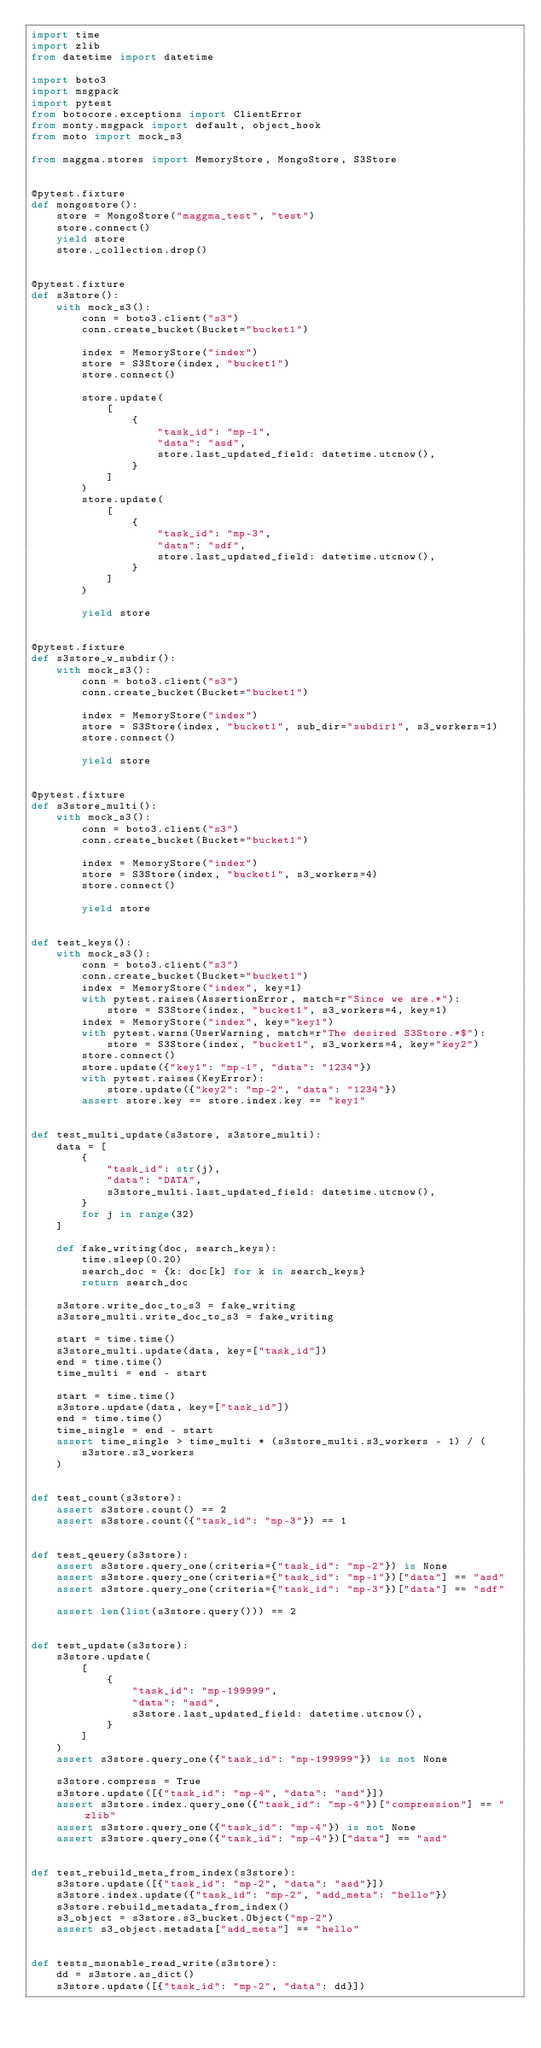<code> <loc_0><loc_0><loc_500><loc_500><_Python_>import time
import zlib
from datetime import datetime

import boto3
import msgpack
import pytest
from botocore.exceptions import ClientError
from monty.msgpack import default, object_hook
from moto import mock_s3

from maggma.stores import MemoryStore, MongoStore, S3Store


@pytest.fixture
def mongostore():
    store = MongoStore("maggma_test", "test")
    store.connect()
    yield store
    store._collection.drop()


@pytest.fixture
def s3store():
    with mock_s3():
        conn = boto3.client("s3")
        conn.create_bucket(Bucket="bucket1")

        index = MemoryStore("index")
        store = S3Store(index, "bucket1")
        store.connect()

        store.update(
            [
                {
                    "task_id": "mp-1",
                    "data": "asd",
                    store.last_updated_field: datetime.utcnow(),
                }
            ]
        )
        store.update(
            [
                {
                    "task_id": "mp-3",
                    "data": "sdf",
                    store.last_updated_field: datetime.utcnow(),
                }
            ]
        )

        yield store


@pytest.fixture
def s3store_w_subdir():
    with mock_s3():
        conn = boto3.client("s3")
        conn.create_bucket(Bucket="bucket1")

        index = MemoryStore("index")
        store = S3Store(index, "bucket1", sub_dir="subdir1", s3_workers=1)
        store.connect()

        yield store


@pytest.fixture
def s3store_multi():
    with mock_s3():
        conn = boto3.client("s3")
        conn.create_bucket(Bucket="bucket1")

        index = MemoryStore("index")
        store = S3Store(index, "bucket1", s3_workers=4)
        store.connect()

        yield store


def test_keys():
    with mock_s3():
        conn = boto3.client("s3")
        conn.create_bucket(Bucket="bucket1")
        index = MemoryStore("index", key=1)
        with pytest.raises(AssertionError, match=r"Since we are.*"):
            store = S3Store(index, "bucket1", s3_workers=4, key=1)
        index = MemoryStore("index", key="key1")
        with pytest.warns(UserWarning, match=r"The desired S3Store.*$"):
            store = S3Store(index, "bucket1", s3_workers=4, key="key2")
        store.connect()
        store.update({"key1": "mp-1", "data": "1234"})
        with pytest.raises(KeyError):
            store.update({"key2": "mp-2", "data": "1234"})
        assert store.key == store.index.key == "key1"


def test_multi_update(s3store, s3store_multi):
    data = [
        {
            "task_id": str(j),
            "data": "DATA",
            s3store_multi.last_updated_field: datetime.utcnow(),
        }
        for j in range(32)
    ]

    def fake_writing(doc, search_keys):
        time.sleep(0.20)
        search_doc = {k: doc[k] for k in search_keys}
        return search_doc

    s3store.write_doc_to_s3 = fake_writing
    s3store_multi.write_doc_to_s3 = fake_writing

    start = time.time()
    s3store_multi.update(data, key=["task_id"])
    end = time.time()
    time_multi = end - start

    start = time.time()
    s3store.update(data, key=["task_id"])
    end = time.time()
    time_single = end - start
    assert time_single > time_multi * (s3store_multi.s3_workers - 1) / (
        s3store.s3_workers
    )


def test_count(s3store):
    assert s3store.count() == 2
    assert s3store.count({"task_id": "mp-3"}) == 1


def test_qeuery(s3store):
    assert s3store.query_one(criteria={"task_id": "mp-2"}) is None
    assert s3store.query_one(criteria={"task_id": "mp-1"})["data"] == "asd"
    assert s3store.query_one(criteria={"task_id": "mp-3"})["data"] == "sdf"

    assert len(list(s3store.query())) == 2


def test_update(s3store):
    s3store.update(
        [
            {
                "task_id": "mp-199999",
                "data": "asd",
                s3store.last_updated_field: datetime.utcnow(),
            }
        ]
    )
    assert s3store.query_one({"task_id": "mp-199999"}) is not None

    s3store.compress = True
    s3store.update([{"task_id": "mp-4", "data": "asd"}])
    assert s3store.index.query_one({"task_id": "mp-4"})["compression"] == "zlib"
    assert s3store.query_one({"task_id": "mp-4"}) is not None
    assert s3store.query_one({"task_id": "mp-4"})["data"] == "asd"


def test_rebuild_meta_from_index(s3store):
    s3store.update([{"task_id": "mp-2", "data": "asd"}])
    s3store.index.update({"task_id": "mp-2", "add_meta": "hello"})
    s3store.rebuild_metadata_from_index()
    s3_object = s3store.s3_bucket.Object("mp-2")
    assert s3_object.metadata["add_meta"] == "hello"


def tests_msonable_read_write(s3store):
    dd = s3store.as_dict()
    s3store.update([{"task_id": "mp-2", "data": dd}])</code> 